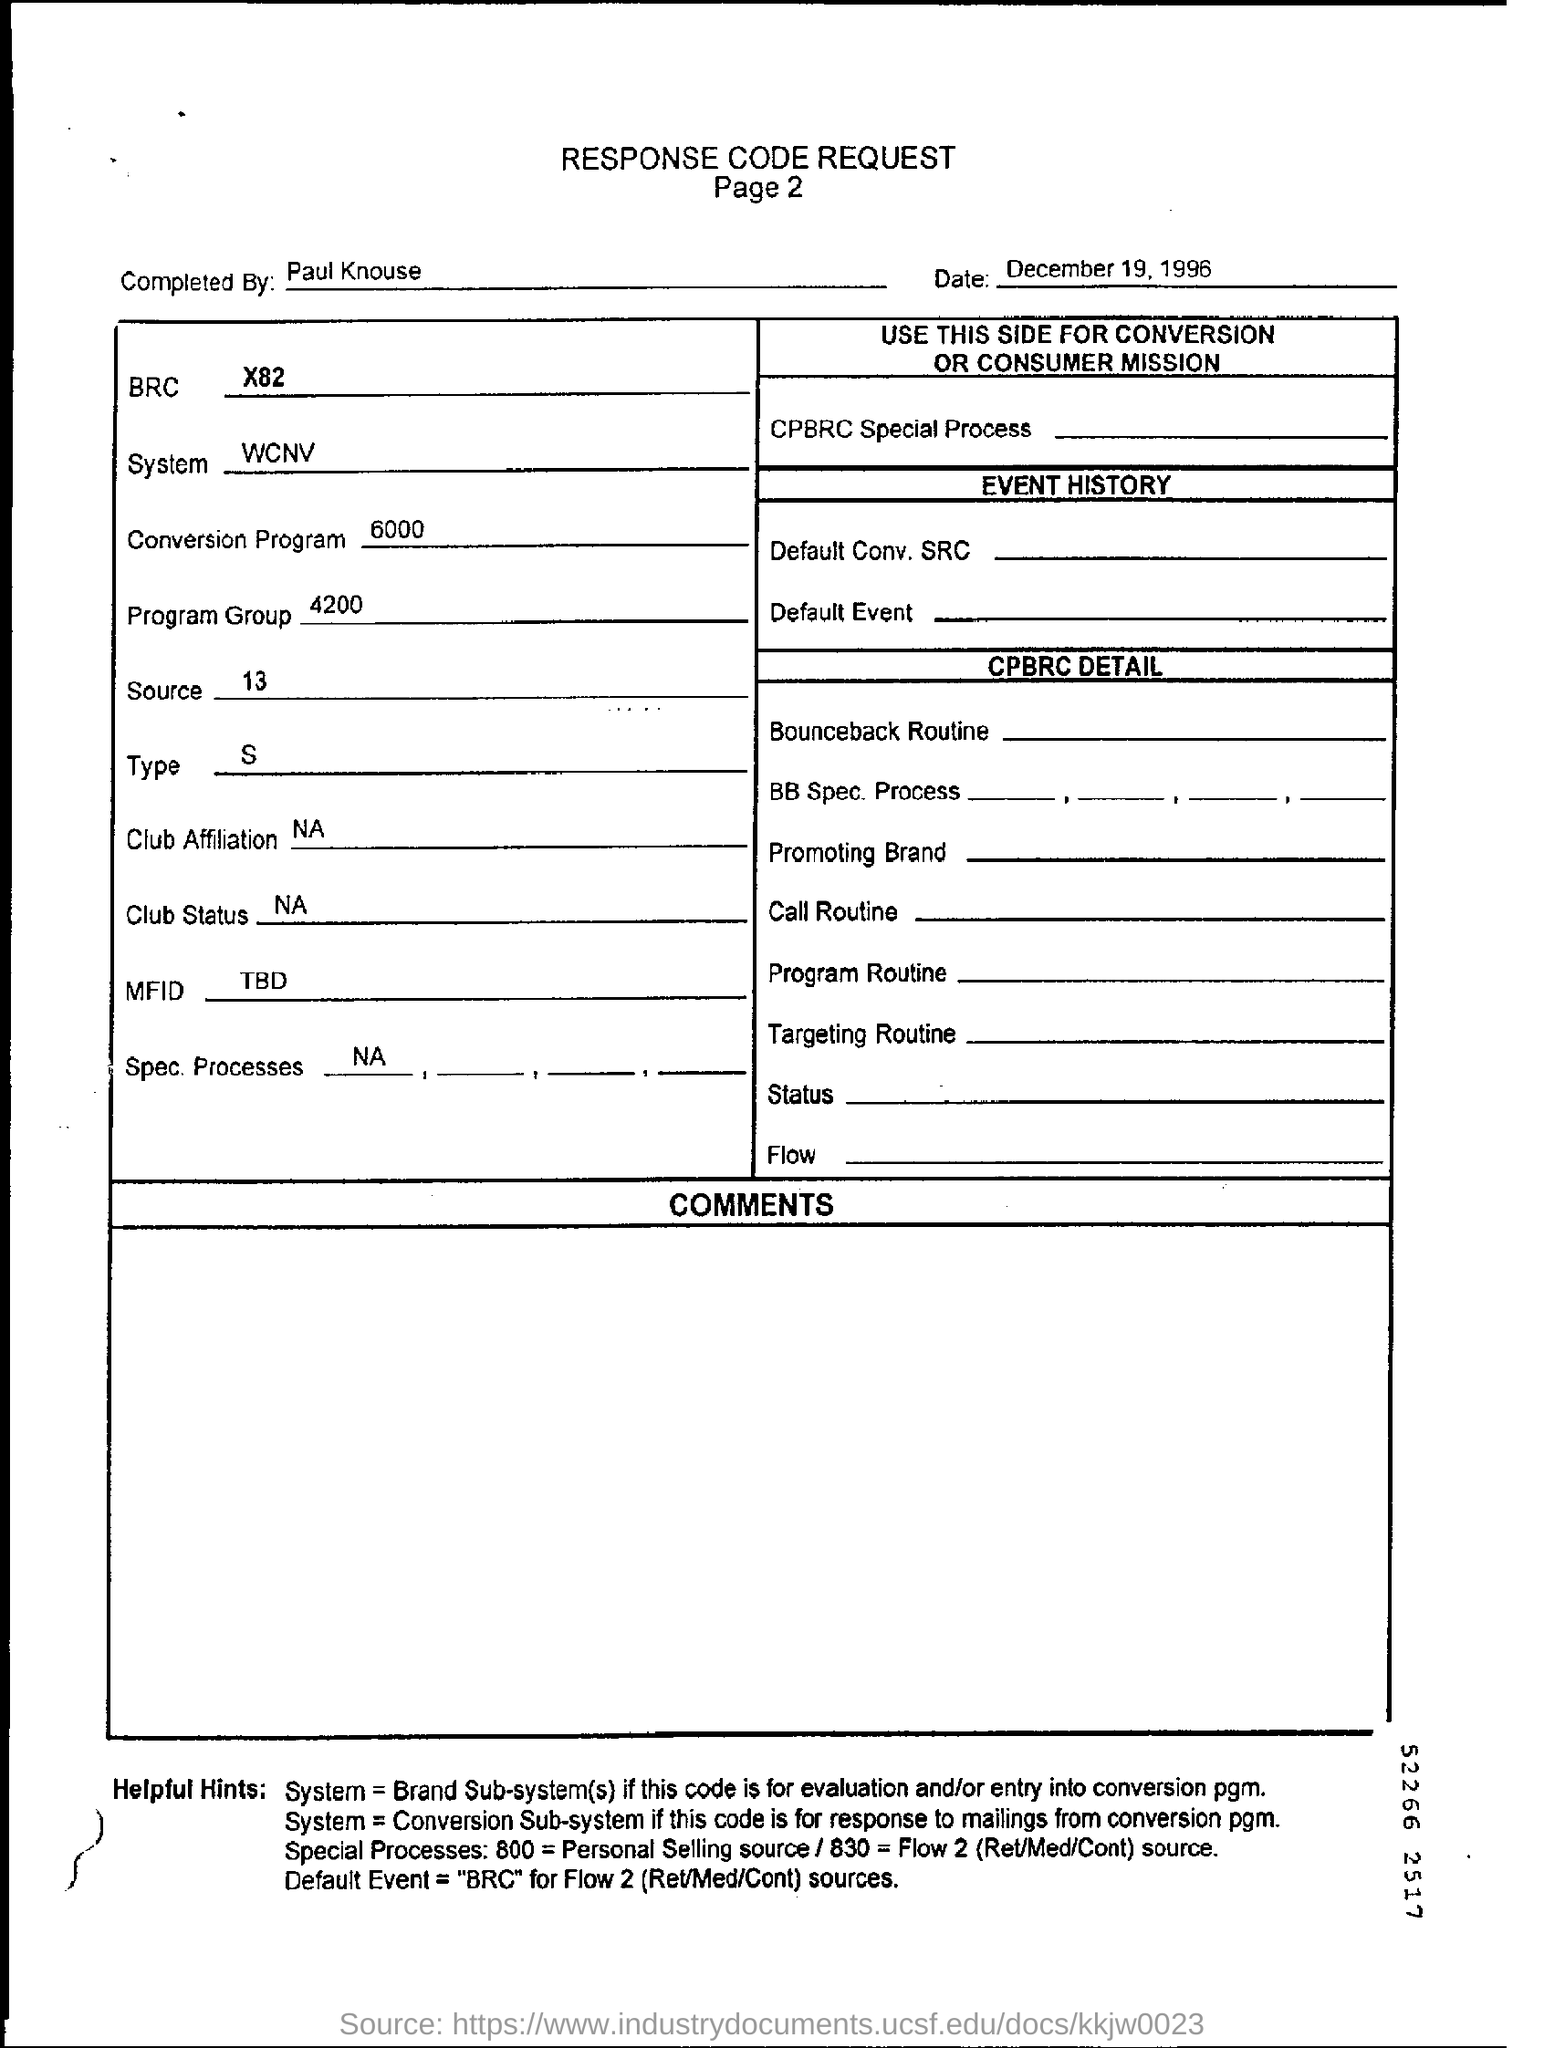Who completed response code request form?
Provide a succinct answer. Paul knouse. When is the response code request form dated?
Offer a very short reply. December 19, 1996. What is the program group number?
Your answer should be compact. 4200. 